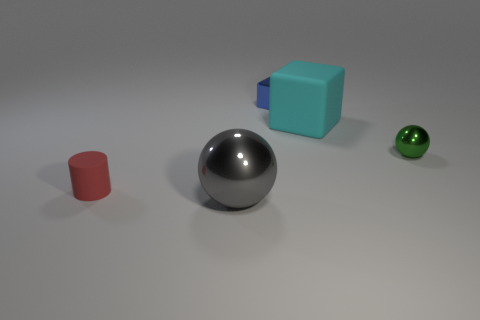Is there anything else that has the same size as the gray ball?
Make the answer very short. Yes. What material is the large thing that is behind the small metal thing that is in front of the big cyan thing made of?
Your response must be concise. Rubber. The thing that is in front of the large cube and right of the large ball has what shape?
Your answer should be compact. Sphere. There is a blue shiny object that is the same shape as the big cyan object; what is its size?
Offer a very short reply. Small. Are there fewer large balls on the right side of the cylinder than large gray metallic things?
Your response must be concise. No. There is a matte block behind the large gray object; what is its size?
Provide a succinct answer. Large. What is the color of the tiny shiny object that is the same shape as the large cyan object?
Offer a very short reply. Blue. Is there anything else that has the same shape as the large gray metal object?
Your answer should be very brief. Yes. Is there a big thing that is right of the metal sphere that is to the left of the metal ball on the right side of the large gray sphere?
Your answer should be very brief. Yes. How many gray spheres have the same material as the green object?
Offer a terse response. 1. 